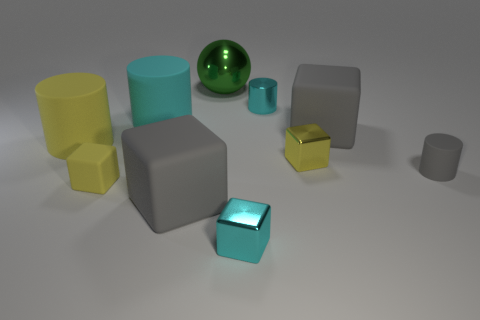Subtract all cyan blocks. How many blocks are left? 4 Subtract all tiny yellow shiny blocks. How many blocks are left? 4 Subtract 2 cubes. How many cubes are left? 3 Subtract all brown cubes. Subtract all yellow balls. How many cubes are left? 5 Subtract all cylinders. How many objects are left? 6 Add 5 big blue matte things. How many big blue matte things exist? 5 Subtract 1 cyan cubes. How many objects are left? 9 Subtract all large gray matte cubes. Subtract all cyan shiny cylinders. How many objects are left? 7 Add 8 yellow cubes. How many yellow cubes are left? 10 